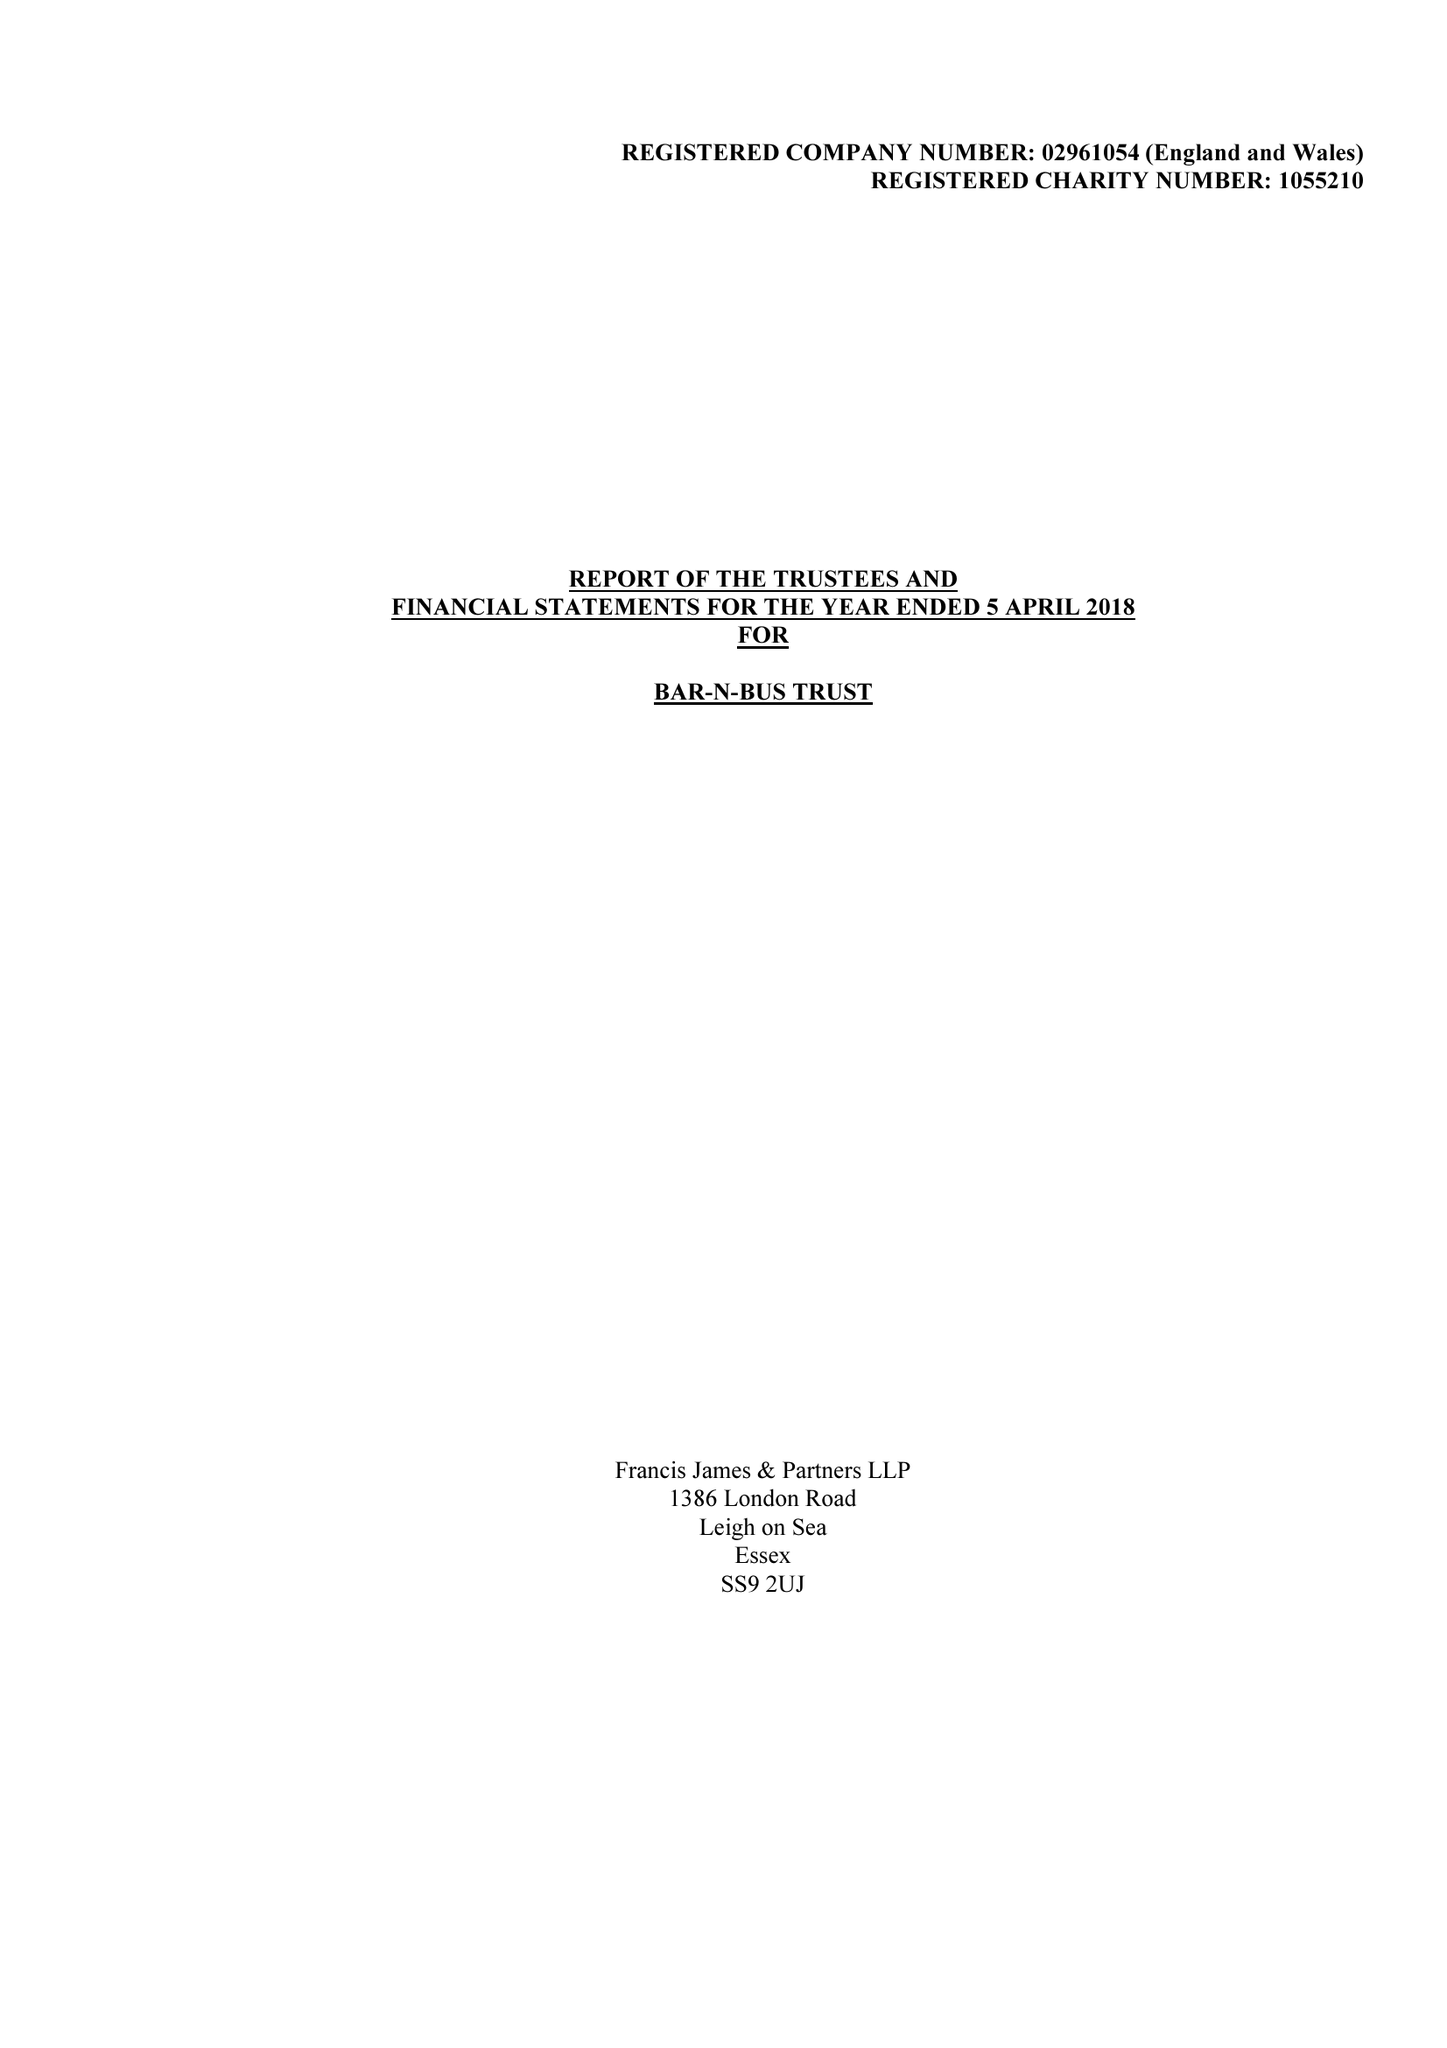What is the value for the address__street_line?
Answer the question using a single word or phrase. 29 CLATTERFIELD GARDENS 